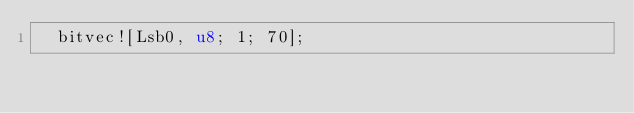Convert code to text. <code><loc_0><loc_0><loc_500><loc_500><_Rust_>	bitvec![Lsb0, u8; 1; 70];</code> 